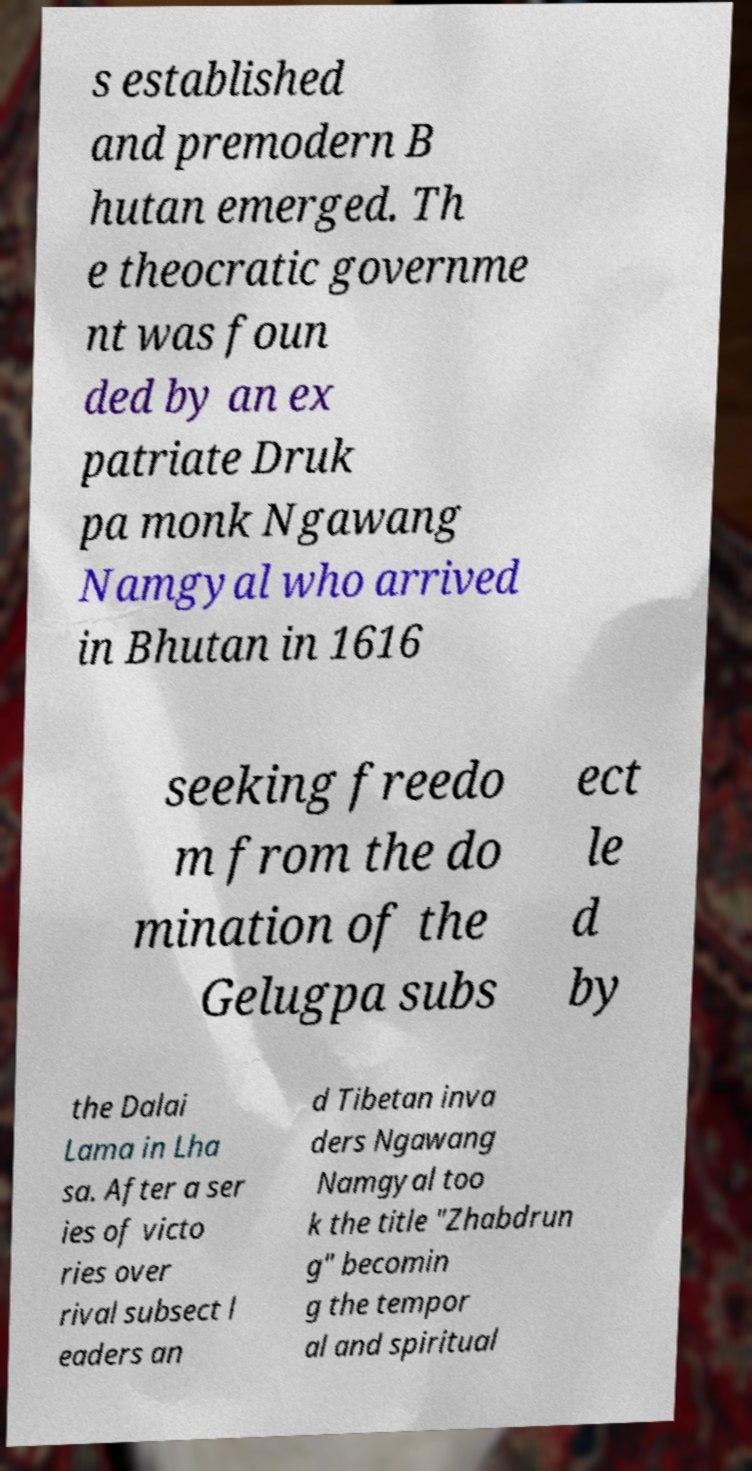Can you accurately transcribe the text from the provided image for me? s established and premodern B hutan emerged. Th e theocratic governme nt was foun ded by an ex patriate Druk pa monk Ngawang Namgyal who arrived in Bhutan in 1616 seeking freedo m from the do mination of the Gelugpa subs ect le d by the Dalai Lama in Lha sa. After a ser ies of victo ries over rival subsect l eaders an d Tibetan inva ders Ngawang Namgyal too k the title "Zhabdrun g" becomin g the tempor al and spiritual 